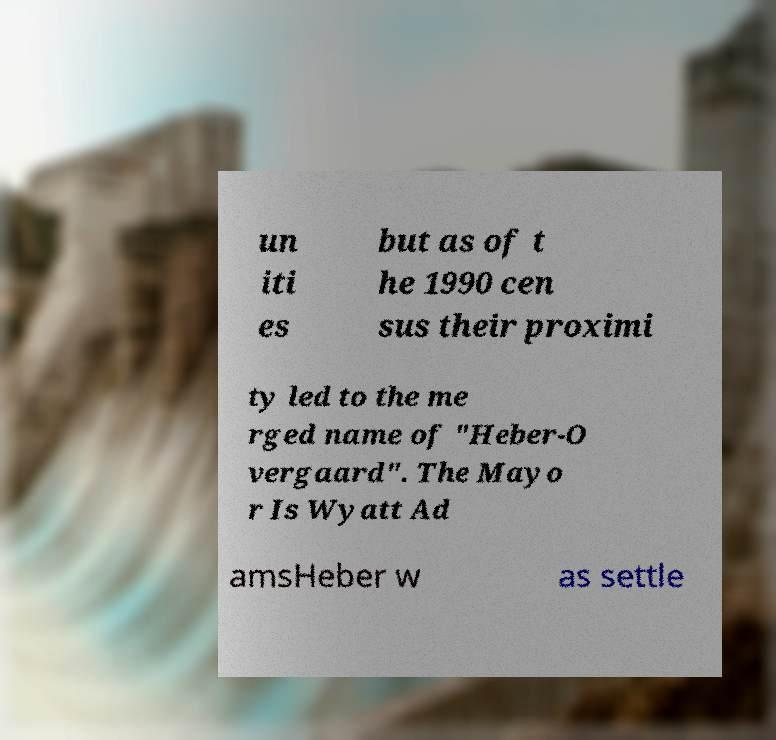Could you extract and type out the text from this image? un iti es but as of t he 1990 cen sus their proximi ty led to the me rged name of "Heber-O vergaard". The Mayo r Is Wyatt Ad amsHeber w as settle 